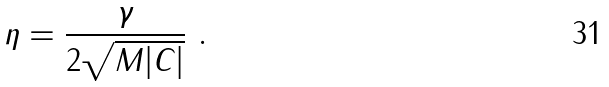Convert formula to latex. <formula><loc_0><loc_0><loc_500><loc_500>\eta = \frac { \gamma } { 2 \sqrt { M | C | } } \ .</formula> 